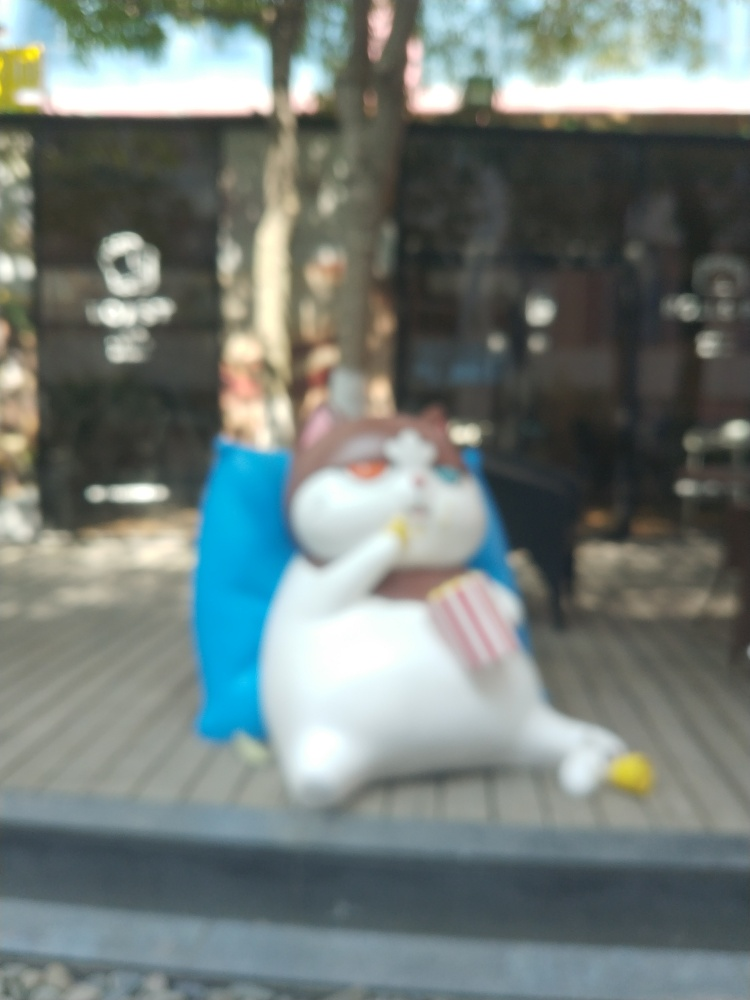Is there noticeable noise or grain? The photo appears blurry rather than grainy, which suggests that the issue is likely due to an out-of-focus lens rather than high ISO noise or grain in the image. 